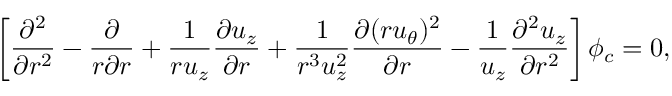Convert formula to latex. <formula><loc_0><loc_0><loc_500><loc_500>\left [ \frac { \partial ^ { 2 } } { \partial r ^ { 2 } } - \frac { \partial } { r \partial r } + \frac { 1 } { r u _ { z } } \frac { \partial u _ { z } } { \partial r } + \frac { 1 } { r ^ { 3 } u _ { z } ^ { 2 } } \frac { \partial ( r u _ { \theta } ) ^ { 2 } } { \partial r } - \frac { 1 } { u _ { z } } \frac { \partial ^ { 2 } u _ { z } } { \partial r ^ { 2 } } \right ] \phi _ { c } = 0 ,</formula> 